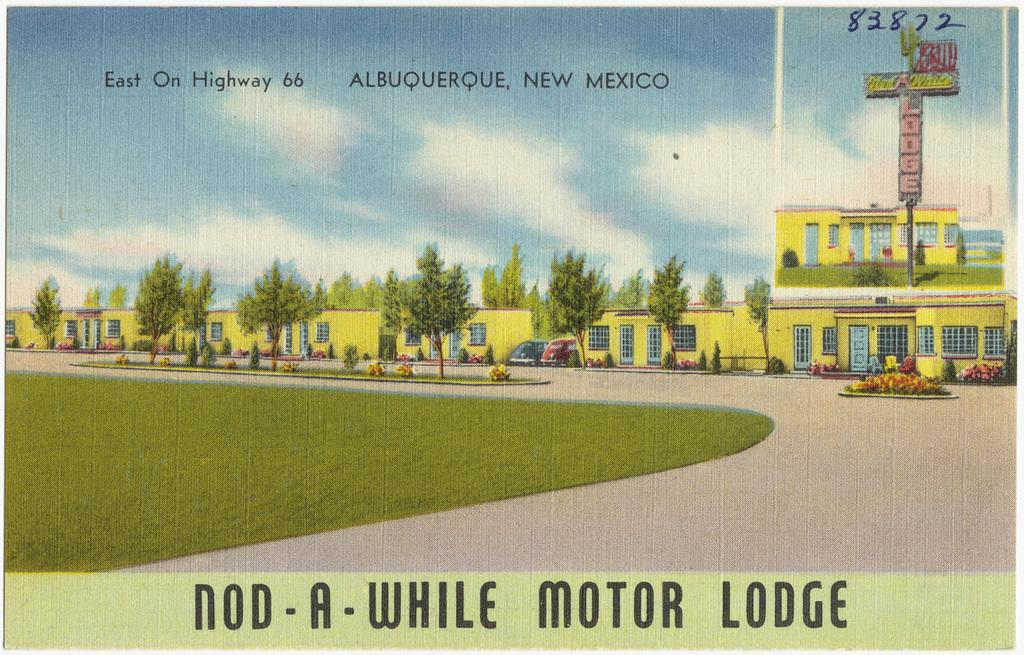<image>
Summarize the visual content of the image. a picture of a Motor Lodge in Albuquerque, New Mexico. 